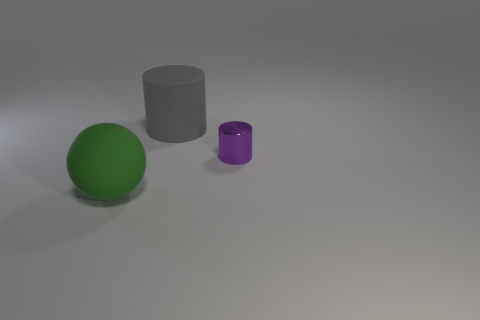What textures can be observed on the objects present in the image? The objects in the image exhibit different textures. The sphere appears to have a smooth, perhaps slightly reflective surface with a uniform green color. The larger cylinder has a matte finish without any shine, implying a rougher texture, and the smaller cylinder looks to have a translucent material with a smooth surface and a purple hue. 